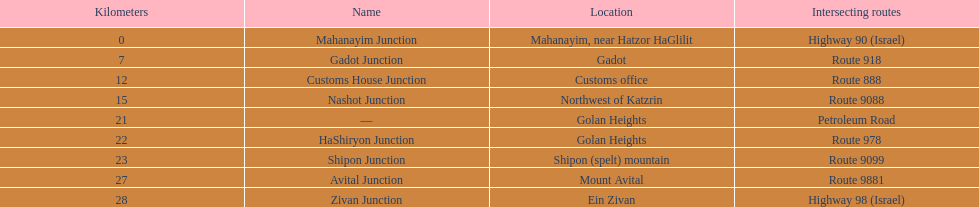What is the count of routes crossing highway 91? 9. 